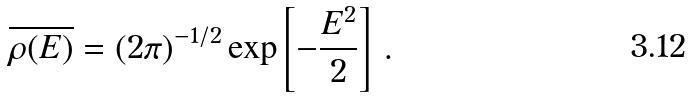Convert formula to latex. <formula><loc_0><loc_0><loc_500><loc_500>\overline { \rho ( E ) } = ( 2 \pi ) ^ { - 1 / 2 } \exp { \left [ - \frac { E ^ { 2 } } { 2 } \right ] } \ .</formula> 